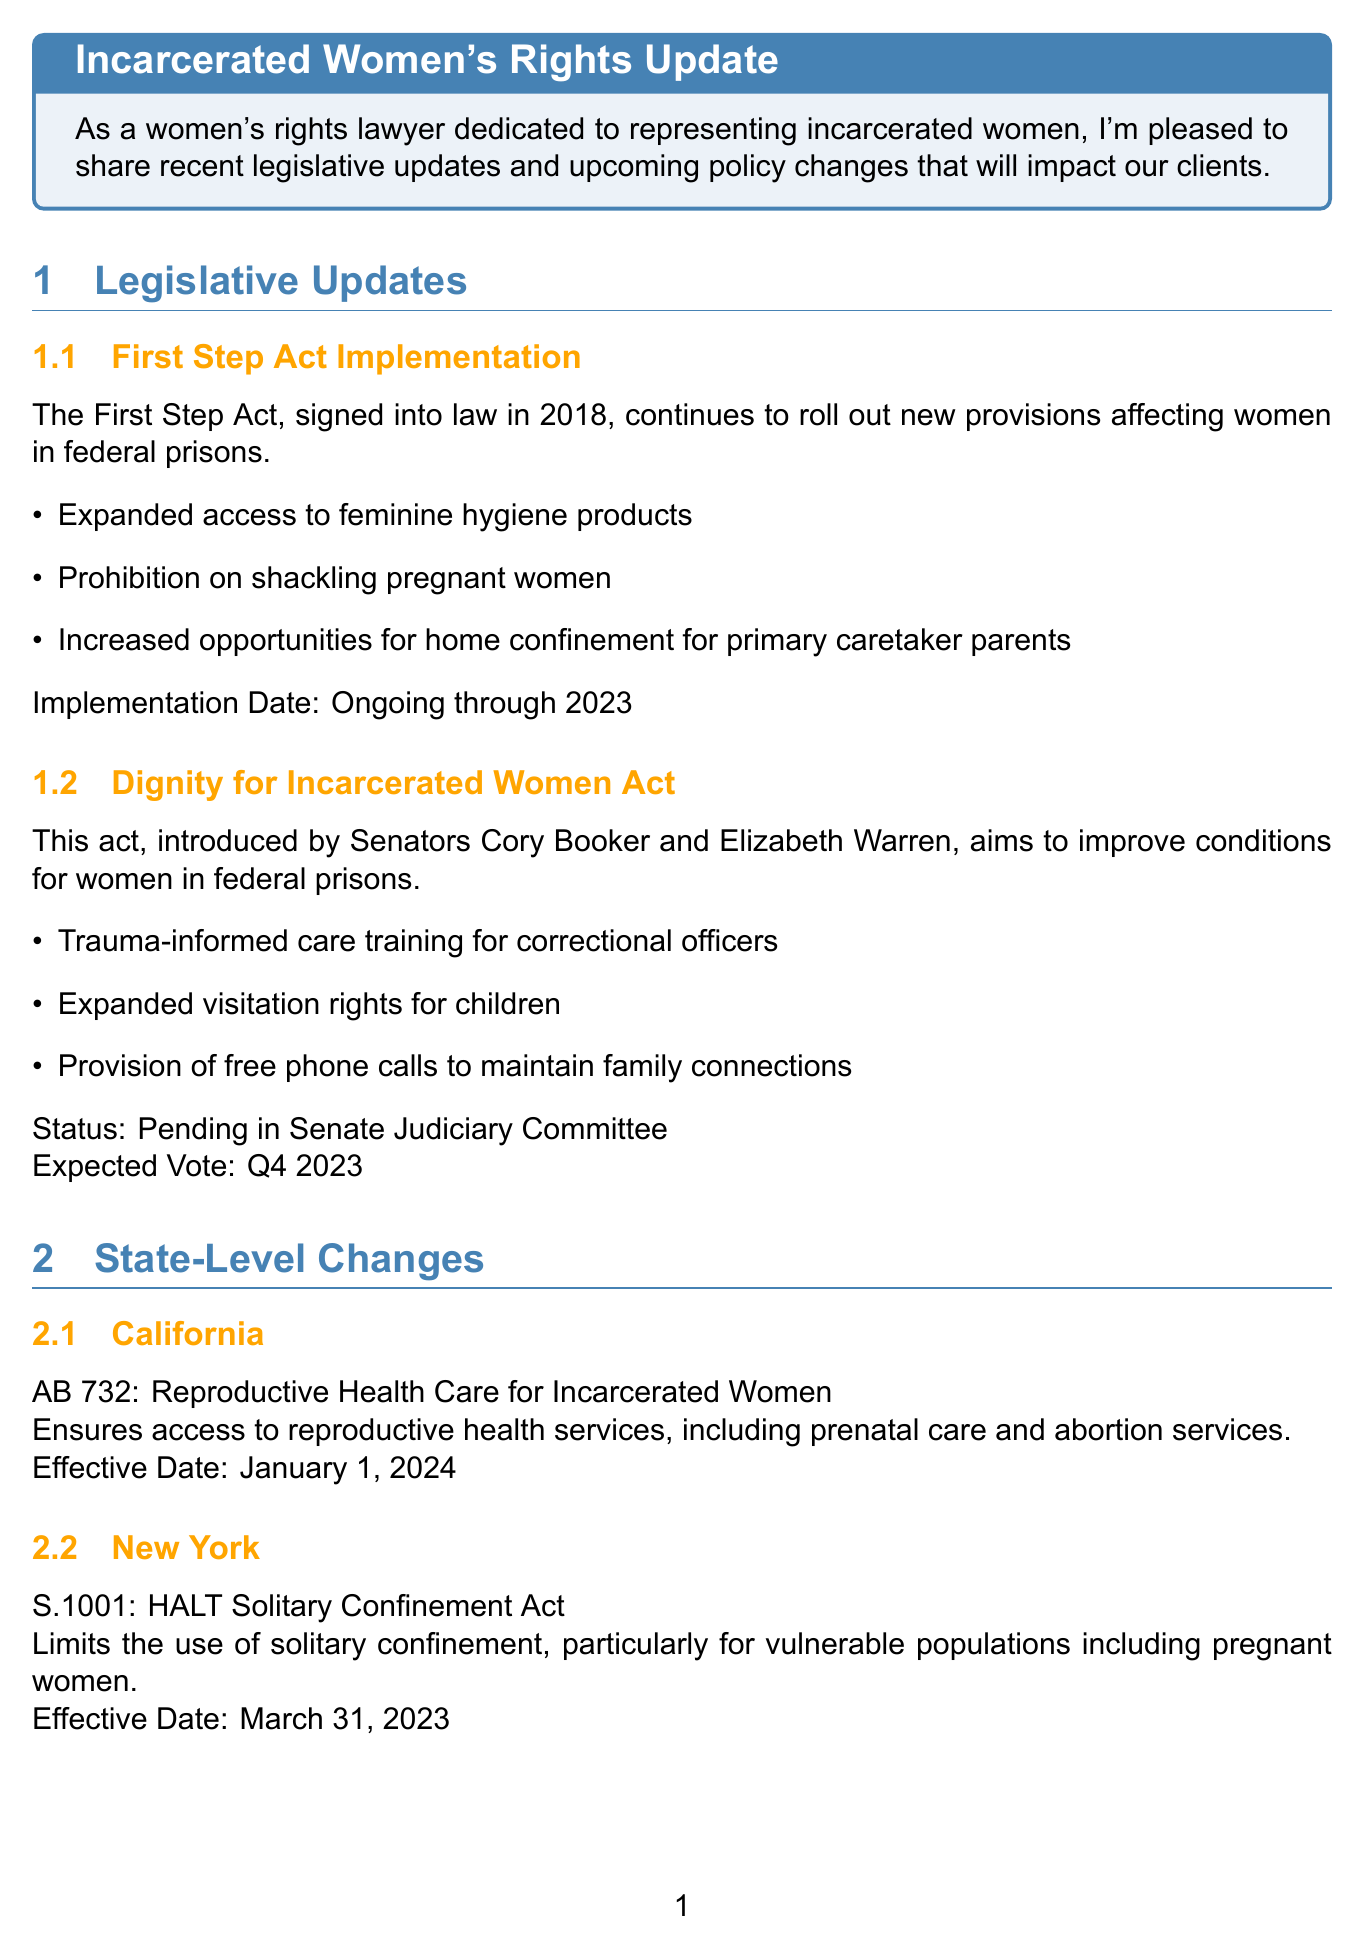What is the title of the newsletter? The title of the newsletter is found at the beginning of the document and summarizes the main focus on incarcerated women's rights.
Answer: Incarcerated Women's Rights Update Who introduced the Dignity for Incarcerated Women Act? The document lists Senators Cory Booker and Elizabeth Warren as the introducers of the Dignity for Incarcerated Women Act.
Answer: Cory Booker and Elizabeth Warren What is the effective date of AB 732 in California? The document specifies the effective date for AB 732, which is related to reproductive health care for incarcerated women in California.
Answer: January 1, 2024 When is the expected vote for the Dignity for Incarcerated Women Act? The expected vote is mentioned in the context of the act's status in the legislative process.
Answer: Q4 2023 What are the expanded visitation rights for? The document states that the expanded visitation rights are specifically for children of incarcerated women as part of the Dignity for Incarcerated Women Act.
Answer: Children How many key points are listed under the First Step Act Implementation? The document enumerates several provisions in the First Step Act, allowing for a count of those key points.
Answer: Three What is the upcoming implementation date for the Women's Health Protection Act? The timeline section identifies the enactment date for the Women's Health Protection Act related to reproductive health care.
Answer: January 1, 2024 What type of care training are correctional officers required to undergo under the Dignity for Incarcerated Women Act? The document mentions specifically the type of training correctional officers will receive under this act.
Answer: Trauma-informed care What is the main call to action in the document? The call to action encourages readers to contact the law office for legal representation for incarcerated women.
Answer: Contact for legal representation 